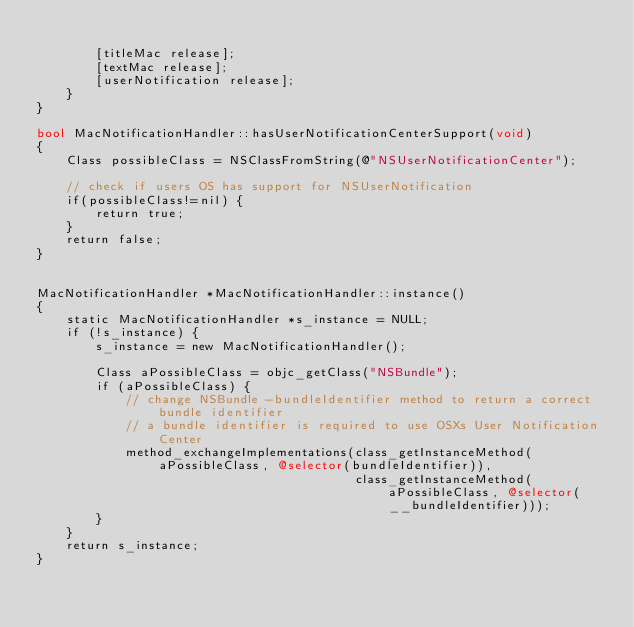<code> <loc_0><loc_0><loc_500><loc_500><_ObjectiveC_>
        [titleMac release];
        [textMac release];
        [userNotification release];
    }
}

bool MacNotificationHandler::hasUserNotificationCenterSupport(void)
{
    Class possibleClass = NSClassFromString(@"NSUserNotificationCenter");

    // check if users OS has support for NSUserNotification
    if(possibleClass!=nil) {
        return true;
    }
    return false;
}


MacNotificationHandler *MacNotificationHandler::instance()
{
    static MacNotificationHandler *s_instance = NULL;
    if (!s_instance) {
        s_instance = new MacNotificationHandler();
        
        Class aPossibleClass = objc_getClass("NSBundle");
        if (aPossibleClass) {
            // change NSBundle -bundleIdentifier method to return a correct bundle identifier
            // a bundle identifier is required to use OSXs User Notification Center
            method_exchangeImplementations(class_getInstanceMethod(aPossibleClass, @selector(bundleIdentifier)),
                                           class_getInstanceMethod(aPossibleClass, @selector(__bundleIdentifier)));
        }
    }
    return s_instance;
}
</code> 